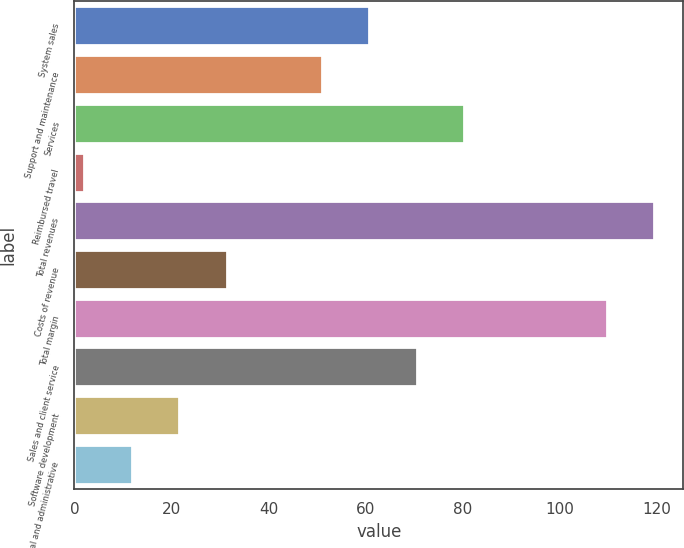Convert chart. <chart><loc_0><loc_0><loc_500><loc_500><bar_chart><fcel>System sales<fcel>Support and maintenance<fcel>Services<fcel>Reimbursed travel<fcel>Total revenues<fcel>Costs of revenue<fcel>Total margin<fcel>Sales and client service<fcel>Software development<fcel>General and administrative<nl><fcel>60.8<fcel>51<fcel>80.4<fcel>2<fcel>119.6<fcel>31.4<fcel>109.8<fcel>70.6<fcel>21.6<fcel>11.8<nl></chart> 